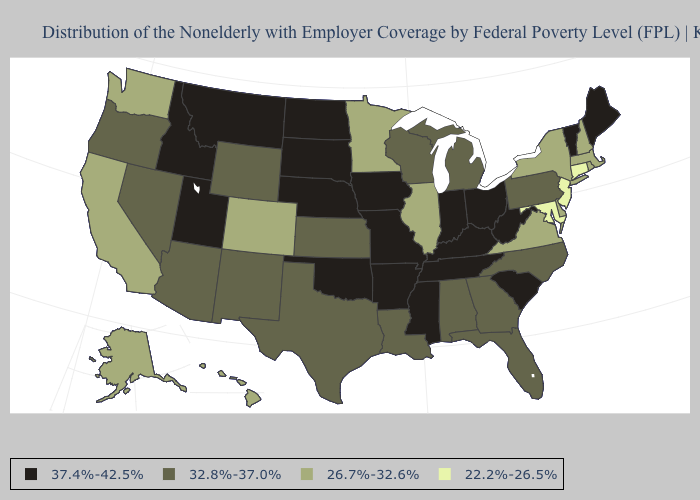Among the states that border Virginia , does West Virginia have the highest value?
Concise answer only. Yes. Which states have the lowest value in the MidWest?
Keep it brief. Illinois, Minnesota. Name the states that have a value in the range 26.7%-32.6%?
Quick response, please. Alaska, California, Colorado, Delaware, Hawaii, Illinois, Massachusetts, Minnesota, New Hampshire, New York, Rhode Island, Virginia, Washington. Name the states that have a value in the range 32.8%-37.0%?
Short answer required. Alabama, Arizona, Florida, Georgia, Kansas, Louisiana, Michigan, Nevada, New Mexico, North Carolina, Oregon, Pennsylvania, Texas, Wisconsin, Wyoming. Does Minnesota have the lowest value in the MidWest?
Write a very short answer. Yes. Which states have the highest value in the USA?
Be succinct. Arkansas, Idaho, Indiana, Iowa, Kentucky, Maine, Mississippi, Missouri, Montana, Nebraska, North Dakota, Ohio, Oklahoma, South Carolina, South Dakota, Tennessee, Utah, Vermont, West Virginia. Name the states that have a value in the range 32.8%-37.0%?
Give a very brief answer. Alabama, Arizona, Florida, Georgia, Kansas, Louisiana, Michigan, Nevada, New Mexico, North Carolina, Oregon, Pennsylvania, Texas, Wisconsin, Wyoming. Which states have the highest value in the USA?
Give a very brief answer. Arkansas, Idaho, Indiana, Iowa, Kentucky, Maine, Mississippi, Missouri, Montana, Nebraska, North Dakota, Ohio, Oklahoma, South Carolina, South Dakota, Tennessee, Utah, Vermont, West Virginia. Which states have the highest value in the USA?
Keep it brief. Arkansas, Idaho, Indiana, Iowa, Kentucky, Maine, Mississippi, Missouri, Montana, Nebraska, North Dakota, Ohio, Oklahoma, South Carolina, South Dakota, Tennessee, Utah, Vermont, West Virginia. Does Arkansas have the lowest value in the USA?
Give a very brief answer. No. Which states have the highest value in the USA?
Give a very brief answer. Arkansas, Idaho, Indiana, Iowa, Kentucky, Maine, Mississippi, Missouri, Montana, Nebraska, North Dakota, Ohio, Oklahoma, South Carolina, South Dakota, Tennessee, Utah, Vermont, West Virginia. Does West Virginia have the lowest value in the South?
Quick response, please. No. Name the states that have a value in the range 32.8%-37.0%?
Concise answer only. Alabama, Arizona, Florida, Georgia, Kansas, Louisiana, Michigan, Nevada, New Mexico, North Carolina, Oregon, Pennsylvania, Texas, Wisconsin, Wyoming. What is the value of Missouri?
Be succinct. 37.4%-42.5%. Name the states that have a value in the range 37.4%-42.5%?
Write a very short answer. Arkansas, Idaho, Indiana, Iowa, Kentucky, Maine, Mississippi, Missouri, Montana, Nebraska, North Dakota, Ohio, Oklahoma, South Carolina, South Dakota, Tennessee, Utah, Vermont, West Virginia. 